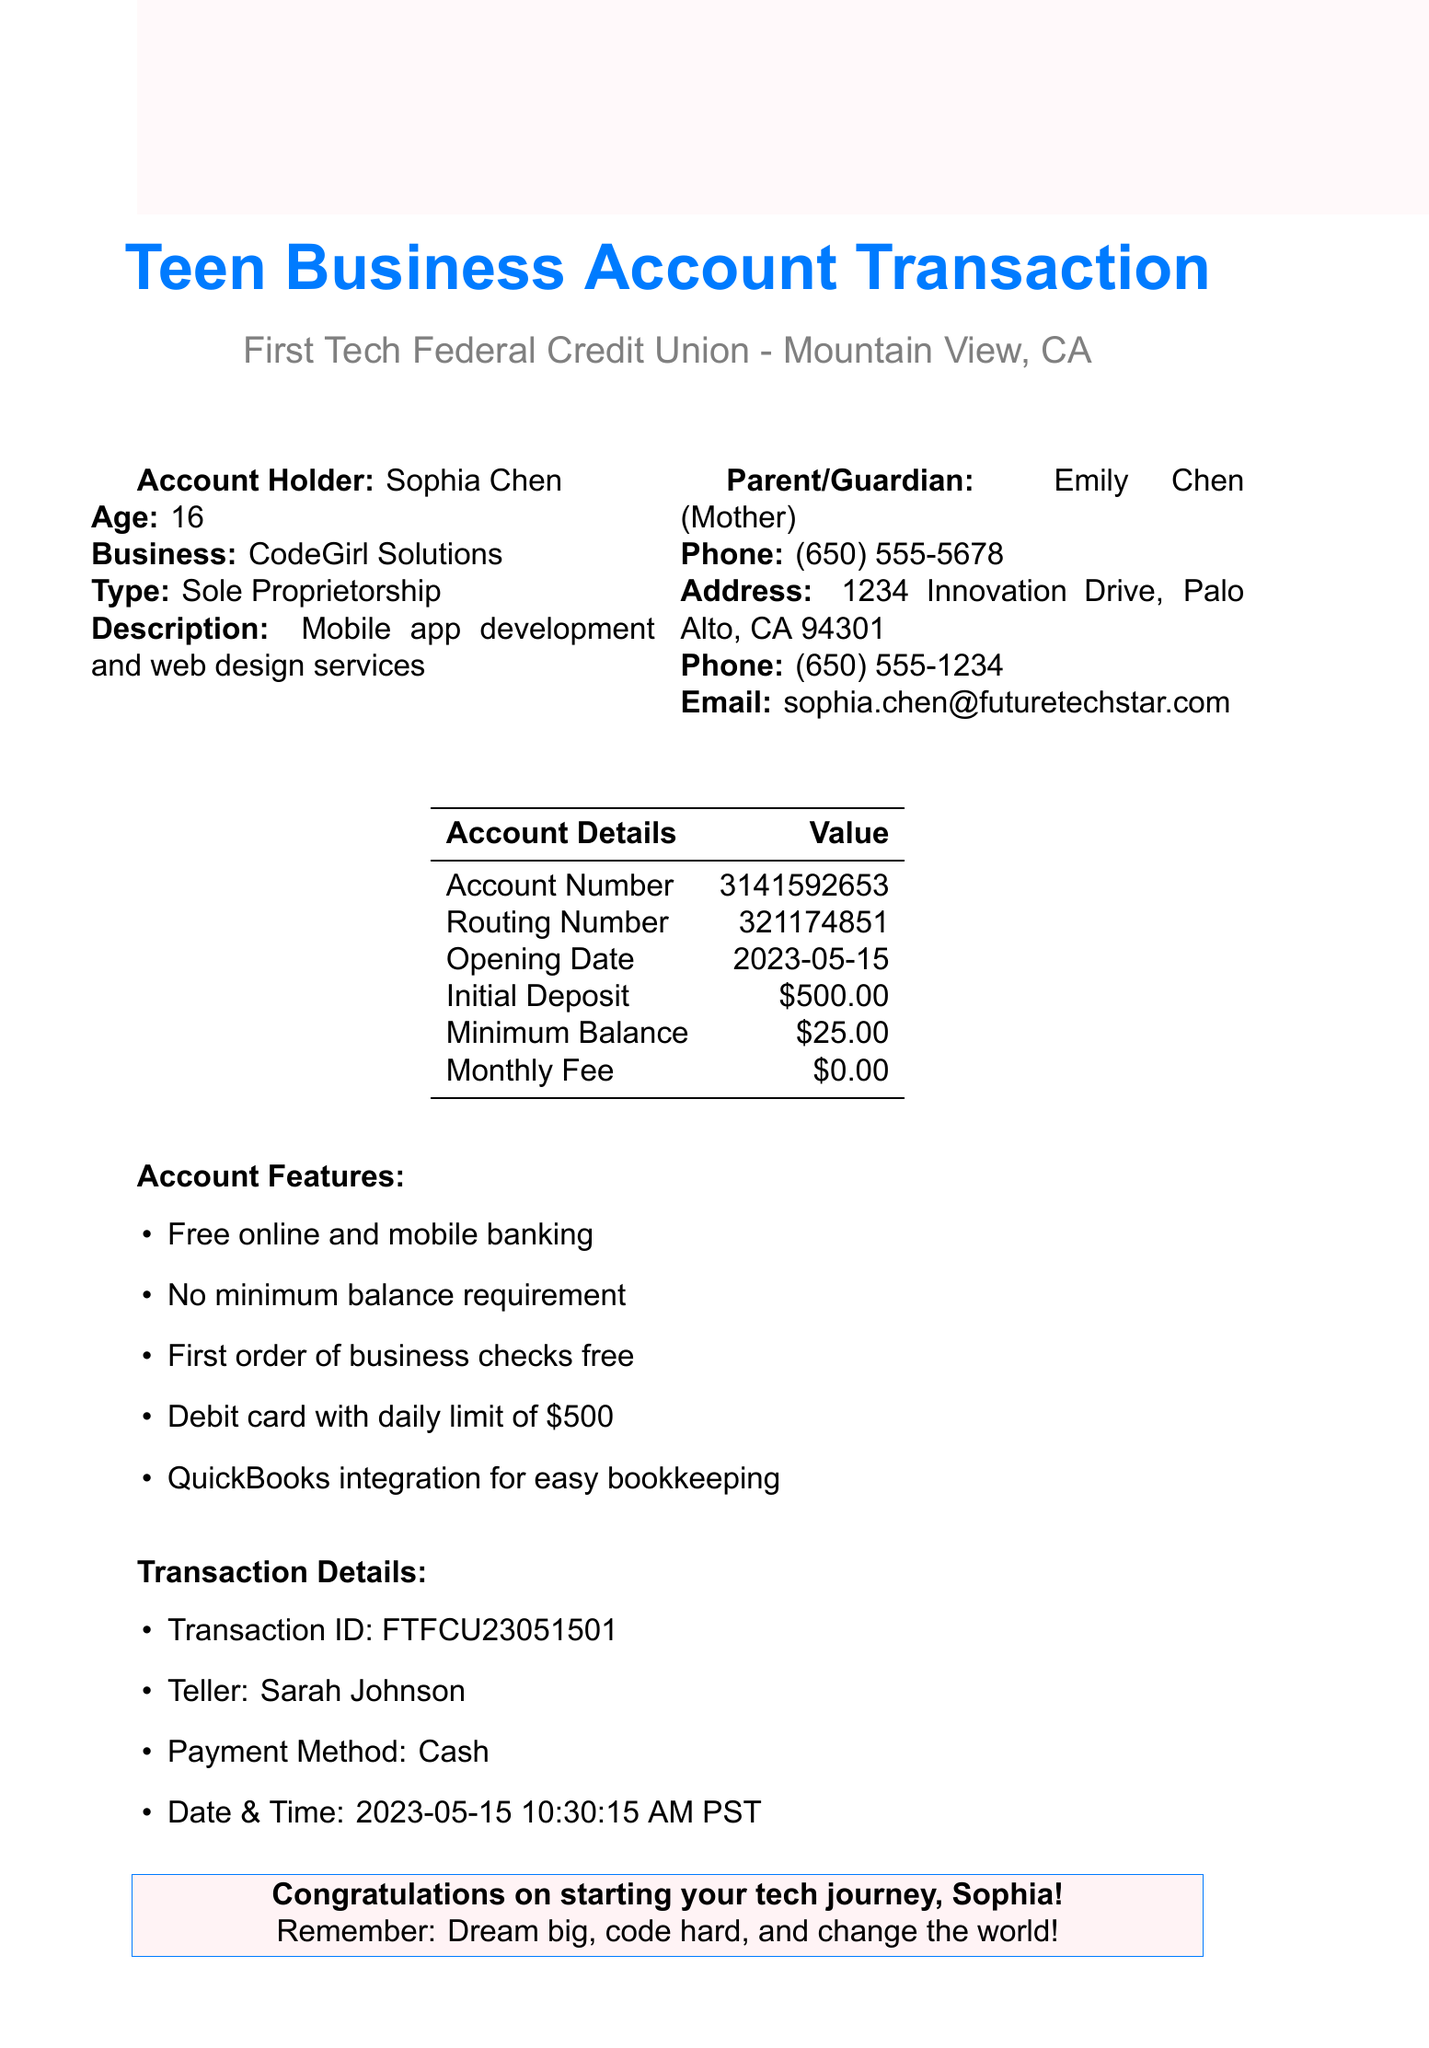What is the name of the bank? The name of the bank is listed at the top of the document, which is First Tech Federal Credit Union.
Answer: First Tech Federal Credit Union Who is the account holder? The document states the account holder's name, which is presented as Sophia Chen.
Answer: Sophia Chen What is the initial deposit amount? The initial deposit is specified in the account details section and is essential for opening the account.
Answer: $500.00 What type of business is CodeGirl Solutions? The document describes the type of business Sophia is starting, which is noted in the business details section.
Answer: Sole Proprietorship What features are offered with the account? The features of the account are listed in a bulleted format, showcasing the perks of this account type.
Answer: Free online and mobile banking What is the account number? The account number is provided within the table of account details, which is necessary for transactions.
Answer: 3141592653 What is the purpose of the required documents section? The required documents section outlines what is necessary for the account opening process, ensuring that all legalities are met.
Answer: To list necessary documents How often is a monthly fee charged? The document specifically states the monthly fee associated with this checking account, indicating it is nil.
Answer: $0.00 Why is a business credit card currently unavailable? The reason for the unavailability of the business credit card is mentioned in the additional services section, reflecting the account’s history requirement.
Answer: Available after 6 months of account history 